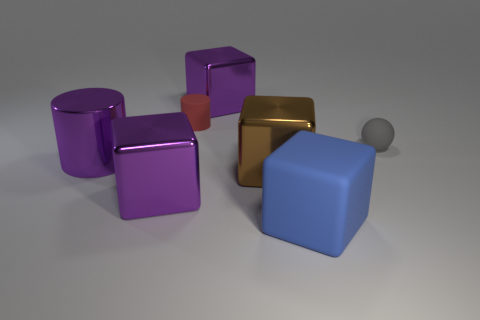There is a matte thing left of the rubber block; does it have the same size as the gray matte sphere?
Keep it short and to the point. Yes. What is the color of the tiny thing that is the same material as the tiny ball?
Keep it short and to the point. Red. There is a brown metal block; how many gray things are behind it?
Keep it short and to the point. 1. There is a rubber thing that is in front of the purple cylinder; is it the same color as the big block that is behind the red cylinder?
Make the answer very short. No. What color is the other object that is the same shape as the red object?
Keep it short and to the point. Purple. Is there anything else that is the same shape as the big brown metal object?
Provide a succinct answer. Yes. There is a metallic thing that is behind the tiny gray matte thing; is its shape the same as the small thing that is on the right side of the small cylinder?
Keep it short and to the point. No. Is the size of the matte cylinder the same as the cylinder that is on the left side of the tiny red rubber cylinder?
Provide a short and direct response. No. Is the number of blue matte objects greater than the number of metallic things?
Your answer should be very brief. No. Are the small thing to the left of the big matte cube and the block that is behind the sphere made of the same material?
Provide a short and direct response. No. 